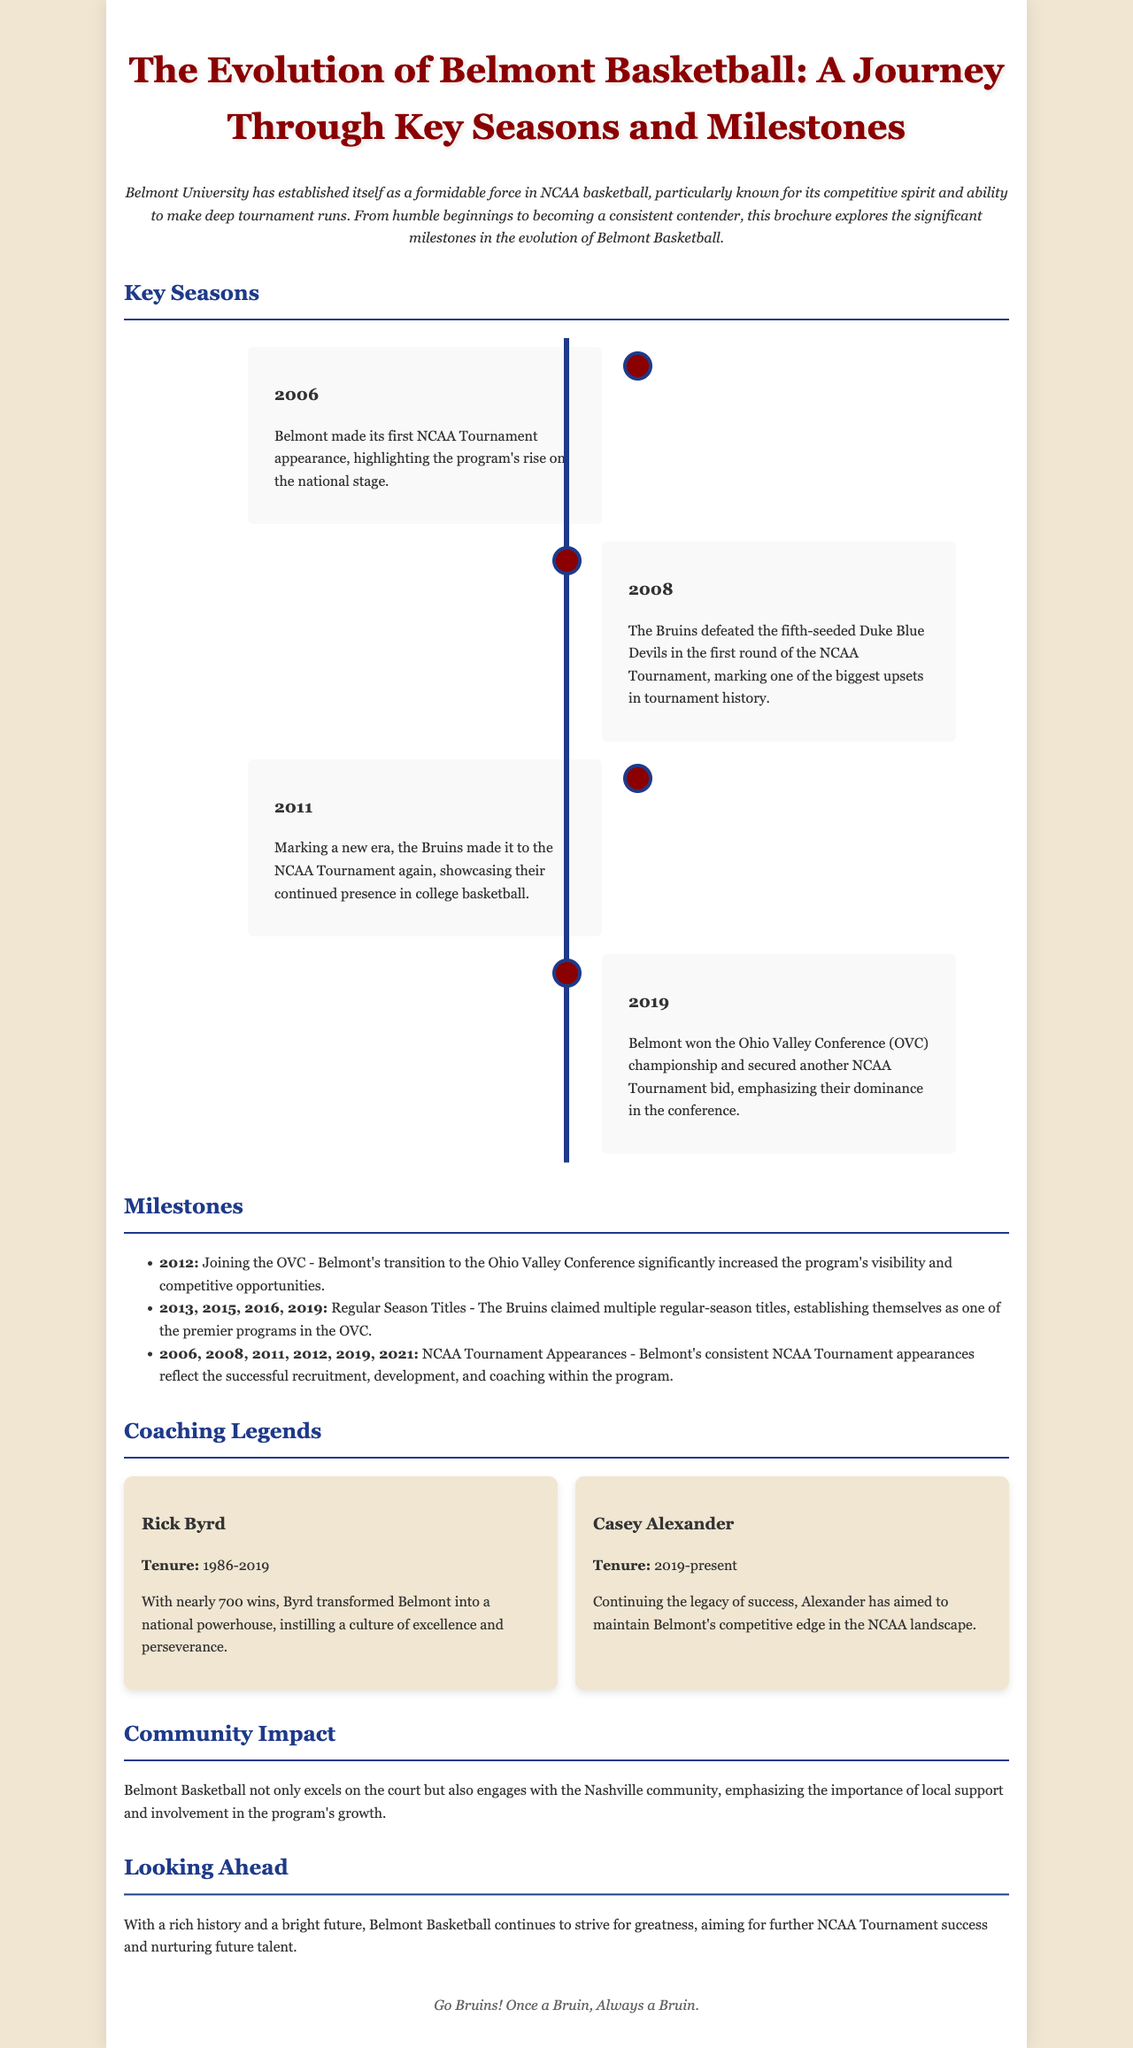what year did Belmont make its first NCAA Tournament appearance? The document mentions that Belmont made its first NCAA Tournament appearance in 2006.
Answer: 2006 which team did Belmont defeat in the 2008 NCAA Tournament? According to the document, Belmont defeated the fifth-seeded Duke Blue Devils in the 2008 NCAA Tournament.
Answer: Duke Blue Devils how many regular-season titles did Belmont claim in the years listed? The document lists four specific years for regular-season titles: 2013, 2015, 2016, and 2019, totaling four titles.
Answer: 4 who was the coach of Belmont from 1986 to 2019? The brochure states that Rick Byrd was the coach from 1986 to 2019.
Answer: Rick Byrd what is the motto mentioned at the end of the brochure? The concluding statement in the document emphasizes loyalty to the team with the phrase "Once a Bruin, Always a Bruin."
Answer: Once a Bruin, Always a Bruin what championship did Belmont win in 2019? The document notes that Belmont won the Ohio Valley Conference championship in 2019.
Answer: Ohio Valley Conference who is the current head coach of Belmont? The brochure mentions Casey Alexander as the current head coach of Belmont, starting from 2019.
Answer: Casey Alexander what significant change occurred in 2012 for Belmont Basketball? The document indicates that Belmont joined the Ohio Valley Conference in 2012, marking a significant transition.
Answer: Joining the OVC 